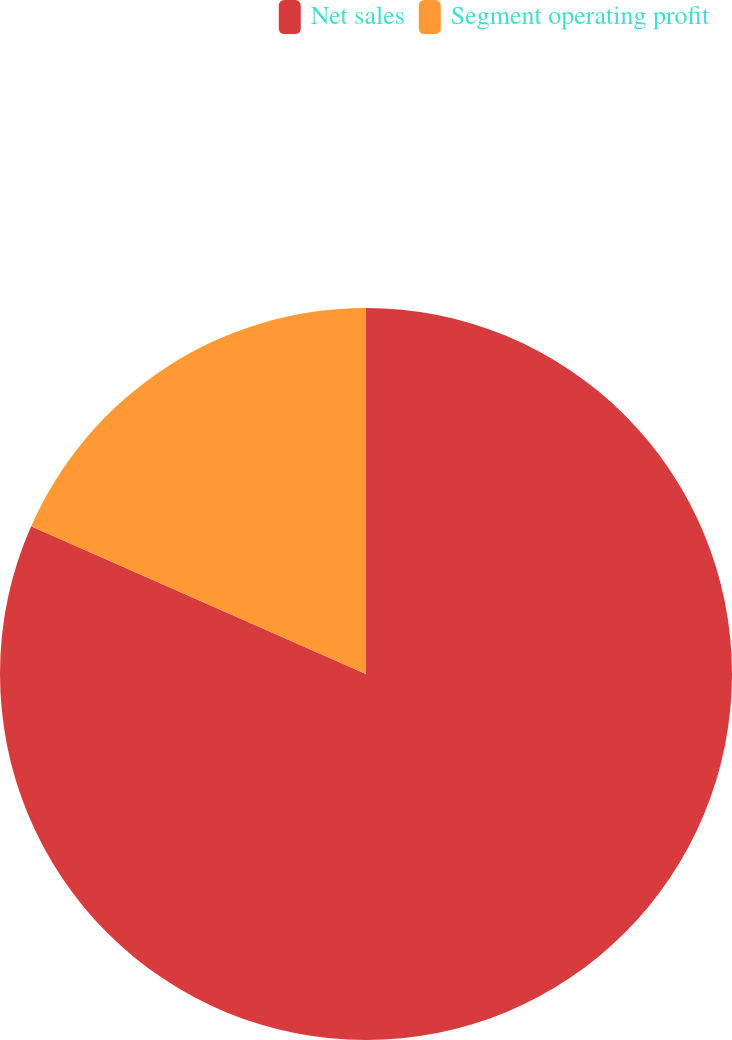Convert chart. <chart><loc_0><loc_0><loc_500><loc_500><pie_chart><fcel>Net sales<fcel>Segment operating profit<nl><fcel>81.61%<fcel>18.39%<nl></chart> 